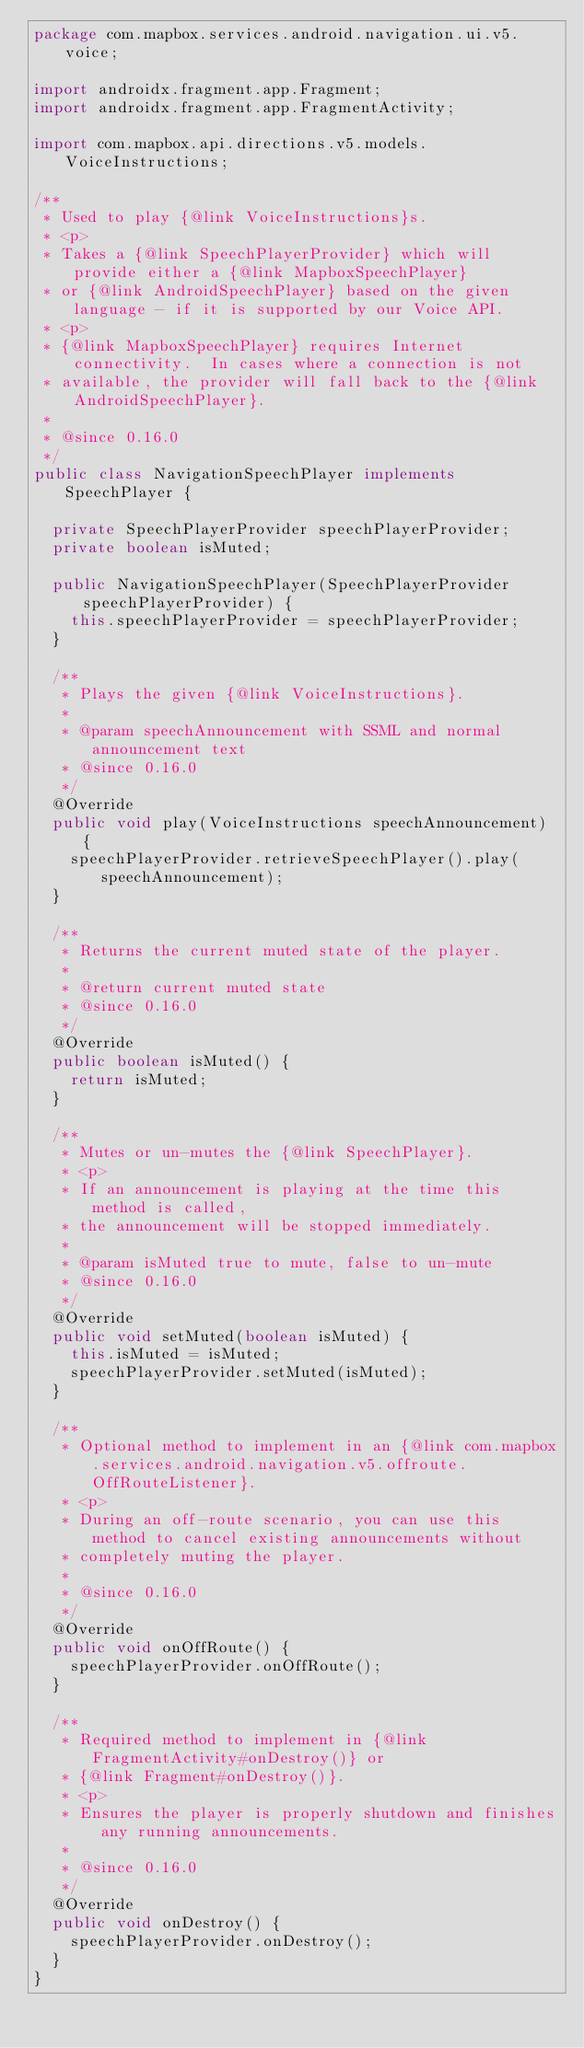<code> <loc_0><loc_0><loc_500><loc_500><_Java_>package com.mapbox.services.android.navigation.ui.v5.voice;

import androidx.fragment.app.Fragment;
import androidx.fragment.app.FragmentActivity;

import com.mapbox.api.directions.v5.models.VoiceInstructions;

/**
 * Used to play {@link VoiceInstructions}s.
 * <p>
 * Takes a {@link SpeechPlayerProvider} which will provide either a {@link MapboxSpeechPlayer}
 * or {@link AndroidSpeechPlayer} based on the given language - if it is supported by our Voice API.
 * <p>
 * {@link MapboxSpeechPlayer} requires Internet connectivity.  In cases where a connection is not
 * available, the provider will fall back to the {@link AndroidSpeechPlayer}.
 *
 * @since 0.16.0
 */
public class NavigationSpeechPlayer implements SpeechPlayer {

  private SpeechPlayerProvider speechPlayerProvider;
  private boolean isMuted;

  public NavigationSpeechPlayer(SpeechPlayerProvider speechPlayerProvider) {
    this.speechPlayerProvider = speechPlayerProvider;
  }

  /**
   * Plays the given {@link VoiceInstructions}.
   *
   * @param speechAnnouncement with SSML and normal announcement text
   * @since 0.16.0
   */
  @Override
  public void play(VoiceInstructions speechAnnouncement) {
    speechPlayerProvider.retrieveSpeechPlayer().play(speechAnnouncement);
  }

  /**
   * Returns the current muted state of the player.
   *
   * @return current muted state
   * @since 0.16.0
   */
  @Override
  public boolean isMuted() {
    return isMuted;
  }

  /**
   * Mutes or un-mutes the {@link SpeechPlayer}.
   * <p>
   * If an announcement is playing at the time this method is called,
   * the announcement will be stopped immediately.
   *
   * @param isMuted true to mute, false to un-mute
   * @since 0.16.0
   */
  @Override
  public void setMuted(boolean isMuted) {
    this.isMuted = isMuted;
    speechPlayerProvider.setMuted(isMuted);
  }

  /**
   * Optional method to implement in an {@link com.mapbox.services.android.navigation.v5.offroute.OffRouteListener}.
   * <p>
   * During an off-route scenario, you can use this method to cancel existing announcements without
   * completely muting the player.
   *
   * @since 0.16.0
   */
  @Override
  public void onOffRoute() {
    speechPlayerProvider.onOffRoute();
  }

  /**
   * Required method to implement in {@link FragmentActivity#onDestroy()} or
   * {@link Fragment#onDestroy()}.
   * <p>
   * Ensures the player is properly shutdown and finishes any running announcements.
   *
   * @since 0.16.0
   */
  @Override
  public void onDestroy() {
    speechPlayerProvider.onDestroy();
  }
}
</code> 